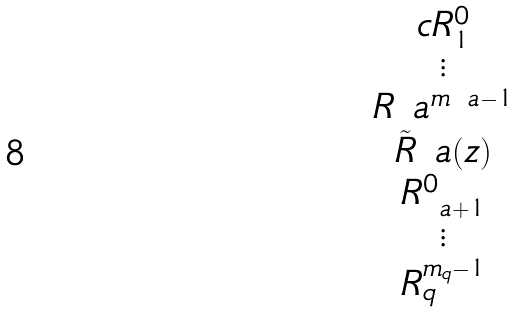Convert formula to latex. <formula><loc_0><loc_0><loc_500><loc_500>\begin{matrix} { c } R _ { 1 } ^ { 0 } \\ \vdots \\ R _ { \ } a ^ { m _ { \ } a - 1 } \\ \tilde { R } _ { \ } a ( z ) \\ R _ { \ a + 1 } ^ { 0 } \\ \vdots \\ R _ { q } ^ { m _ { q } - 1 } \end{matrix}</formula> 